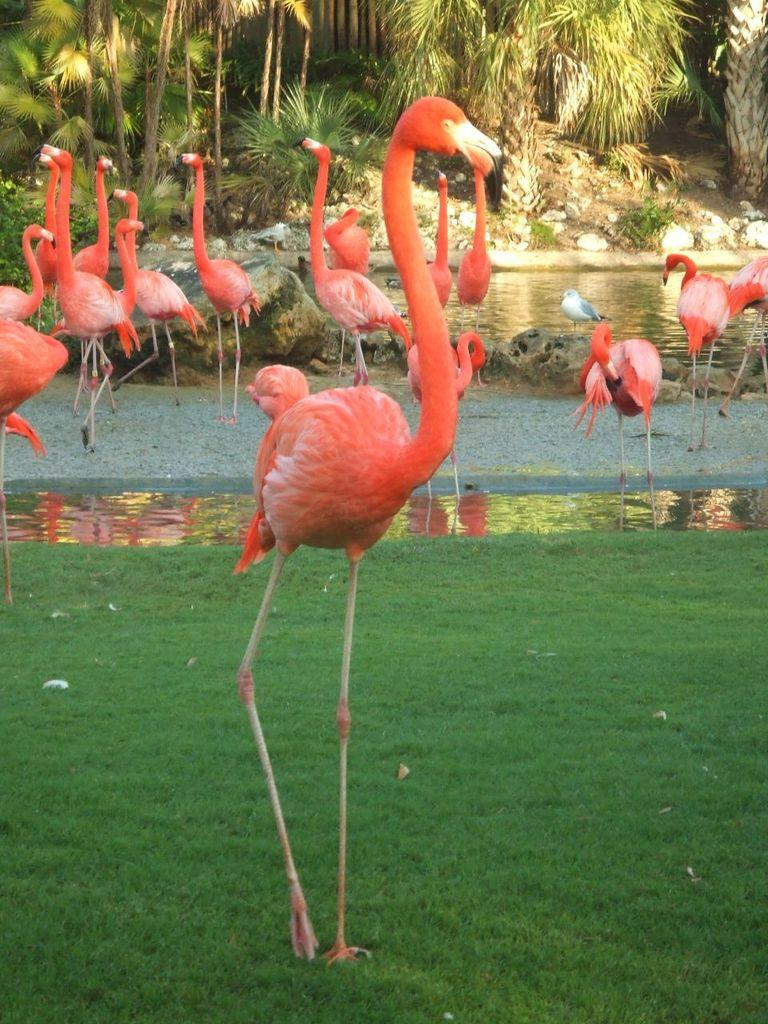What type of animals can be seen in the image? There are many birds in the image. What is on the ground in the image? There are grasses on the ground in the image. What is visible in the image besides the birds and grasses? There is water visible in the image. What can be seen in the background of the image? There are many trees in the background of the image. What type of horn can be seen on the scarecrow in the image? There is no scarecrow or horn present in the image. What type of bread is being used to feed the birds in the image? There is no bread or feeding of birds depicted in the image. 